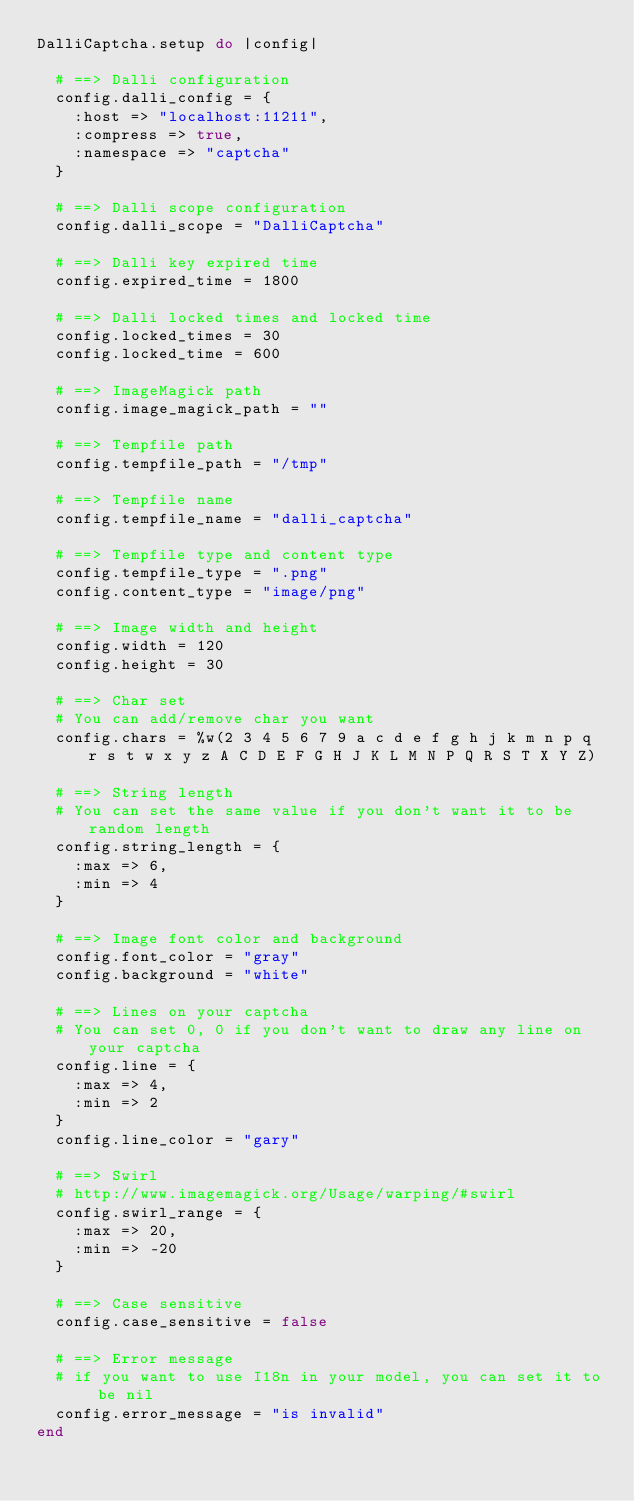Convert code to text. <code><loc_0><loc_0><loc_500><loc_500><_Ruby_>DalliCaptcha.setup do |config|

  # ==> Dalli configuration
  config.dalli_config = {
    :host => "localhost:11211",
    :compress => true,
    :namespace => "captcha"
  }

  # ==> Dalli scope configuration
  config.dalli_scope = "DalliCaptcha"

  # ==> Dalli key expired time
  config.expired_time = 1800

  # ==> Dalli locked times and locked time
  config.locked_times = 30
  config.locked_time = 600

  # ==> ImageMagick path
  config.image_magick_path = ""

  # ==> Tempfile path
  config.tempfile_path = "/tmp"

  # ==> Tempfile name
  config.tempfile_name = "dalli_captcha"

  # ==> Tempfile type and content type
  config.tempfile_type = ".png"
  config.content_type = "image/png"

  # ==> Image width and height
  config.width = 120
  config.height = 30

  # ==> Char set
  # You can add/remove char you want
  config.chars = %w(2 3 4 5 6 7 9 a c d e f g h j k m n p q r s t w x y z A C D E F G H J K L M N P Q R S T X Y Z)

  # ==> String length
  # You can set the same value if you don't want it to be random length
  config.string_length = {
    :max => 6,
    :min => 4
  }

  # ==> Image font color and background
  config.font_color = "gray"
  config.background = "white"

  # ==> Lines on your captcha
  # You can set 0, 0 if you don't want to draw any line on your captcha
  config.line = {
    :max => 4,
    :min => 2
  }
  config.line_color = "gary"

  # ==> Swirl
  # http://www.imagemagick.org/Usage/warping/#swirl
  config.swirl_range = {
    :max => 20,
    :min => -20
  }

  # ==> Case sensitive
  config.case_sensitive = false

  # ==> Error message
  # if you want to use I18n in your model, you can set it to be nil
  config.error_message = "is invalid"
end
</code> 